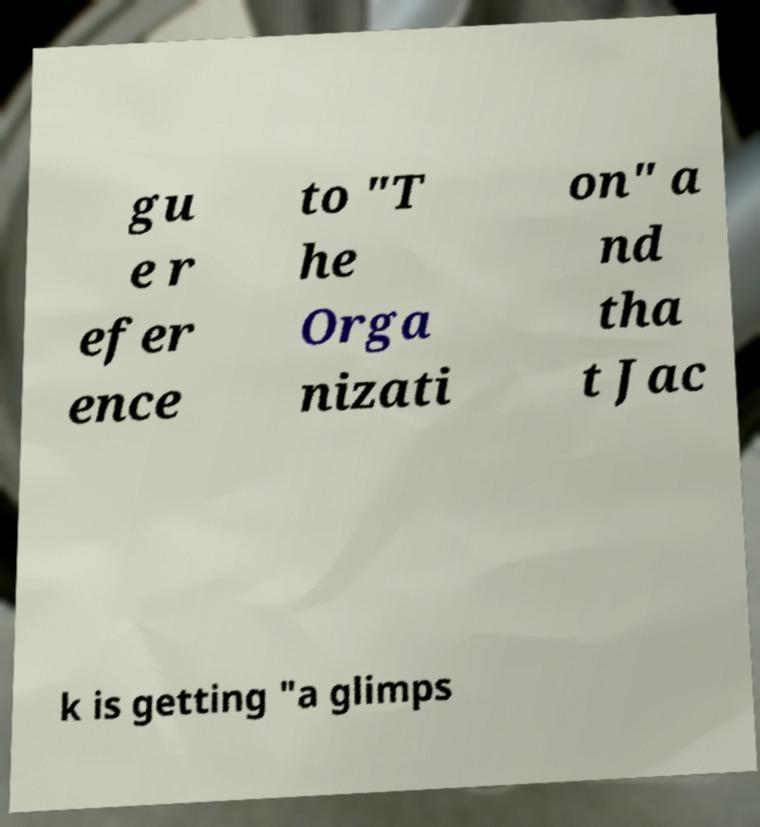Can you read and provide the text displayed in the image?This photo seems to have some interesting text. Can you extract and type it out for me? gu e r efer ence to "T he Orga nizati on" a nd tha t Jac k is getting "a glimps 